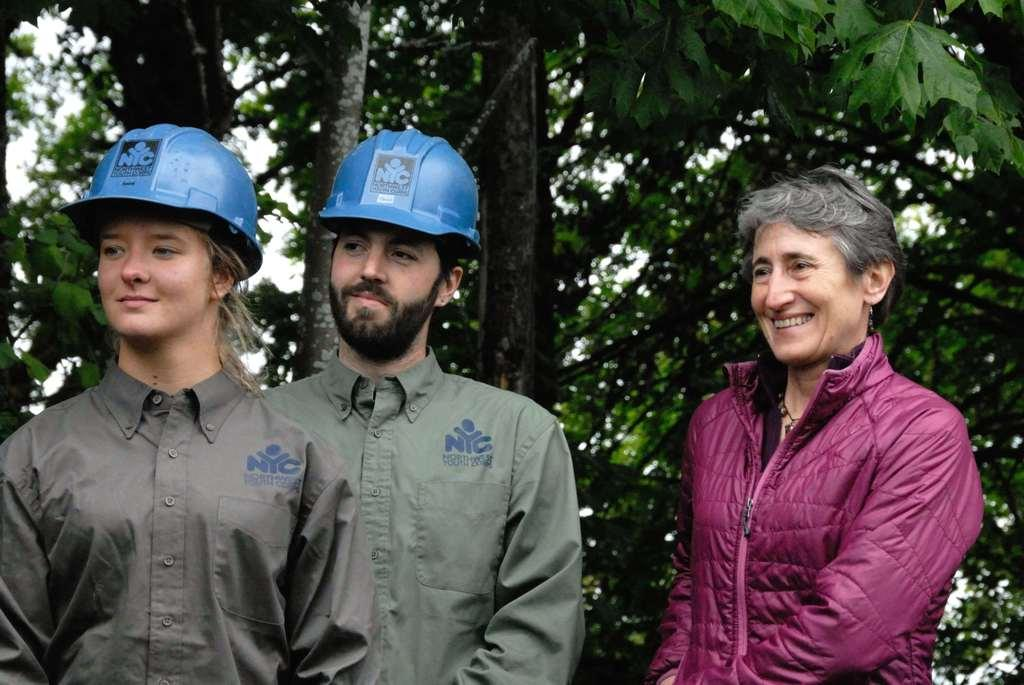How many people are in the image? There are three people in the image. What are the people doing in the image? The three people are standing. What expressions do the people have in the image? The three people are smiling. What are two of the people wearing in the image? Two of the people are wearing helmets. What can be seen in the background of the image? There are trees in the background of the image. What type of arithmetic problem can be seen being solved by the sheep in the image? There are no sheep present in the image, and therefore no arithmetic problem can be observed. 